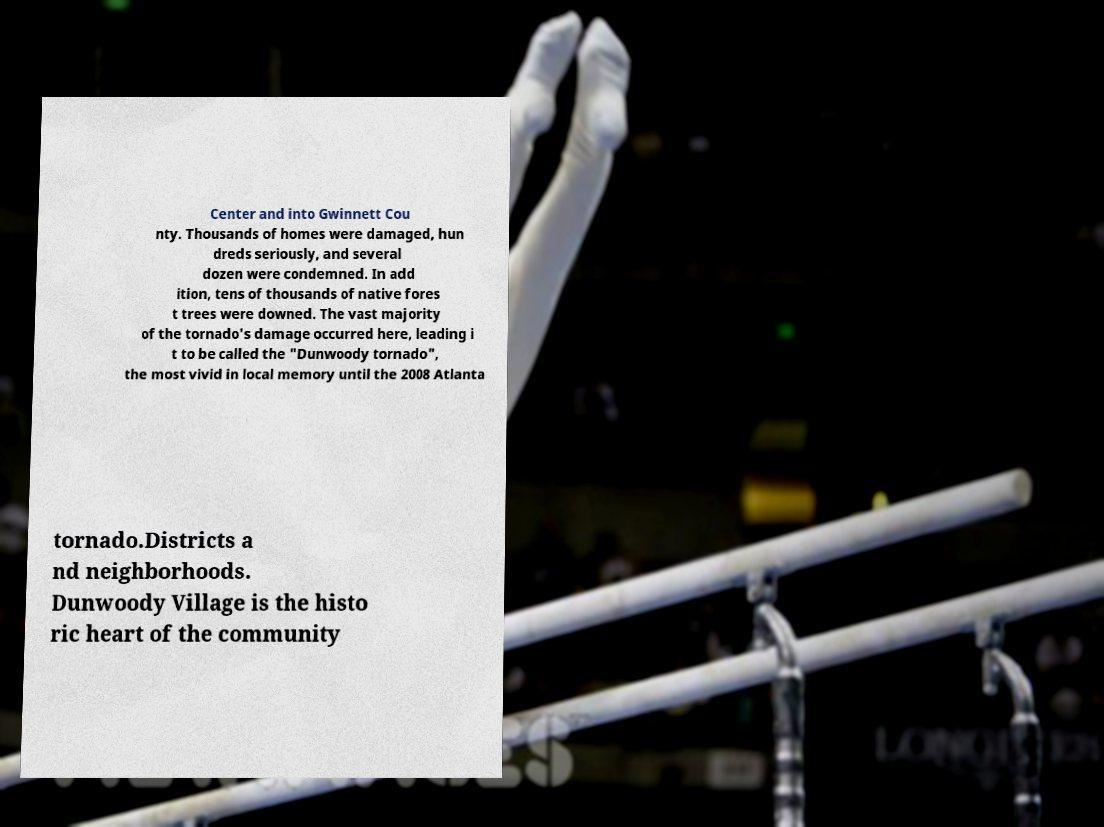Can you accurately transcribe the text from the provided image for me? Center and into Gwinnett Cou nty. Thousands of homes were damaged, hun dreds seriously, and several dozen were condemned. In add ition, tens of thousands of native fores t trees were downed. The vast majority of the tornado's damage occurred here, leading i t to be called the "Dunwoody tornado", the most vivid in local memory until the 2008 Atlanta tornado.Districts a nd neighborhoods. Dunwoody Village is the histo ric heart of the community 